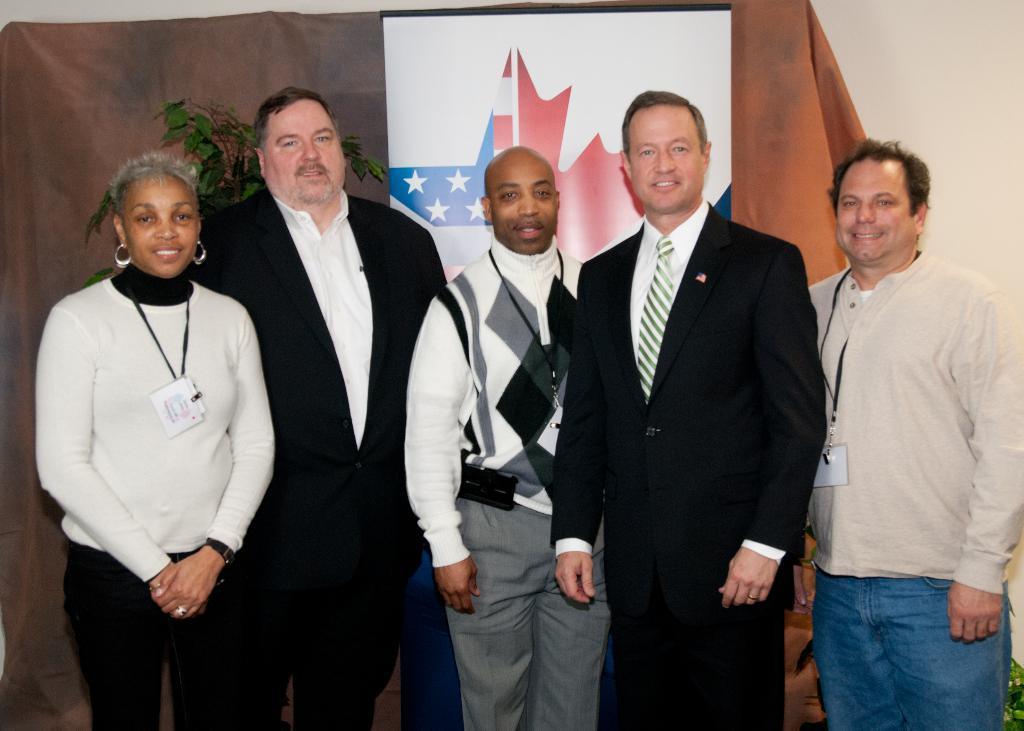Please provide a concise description of this image. There are persons in different color dresses, smiling and standing. In the background, there is a banner, back to this, there is a curtain, near a plant and there is white wall. 